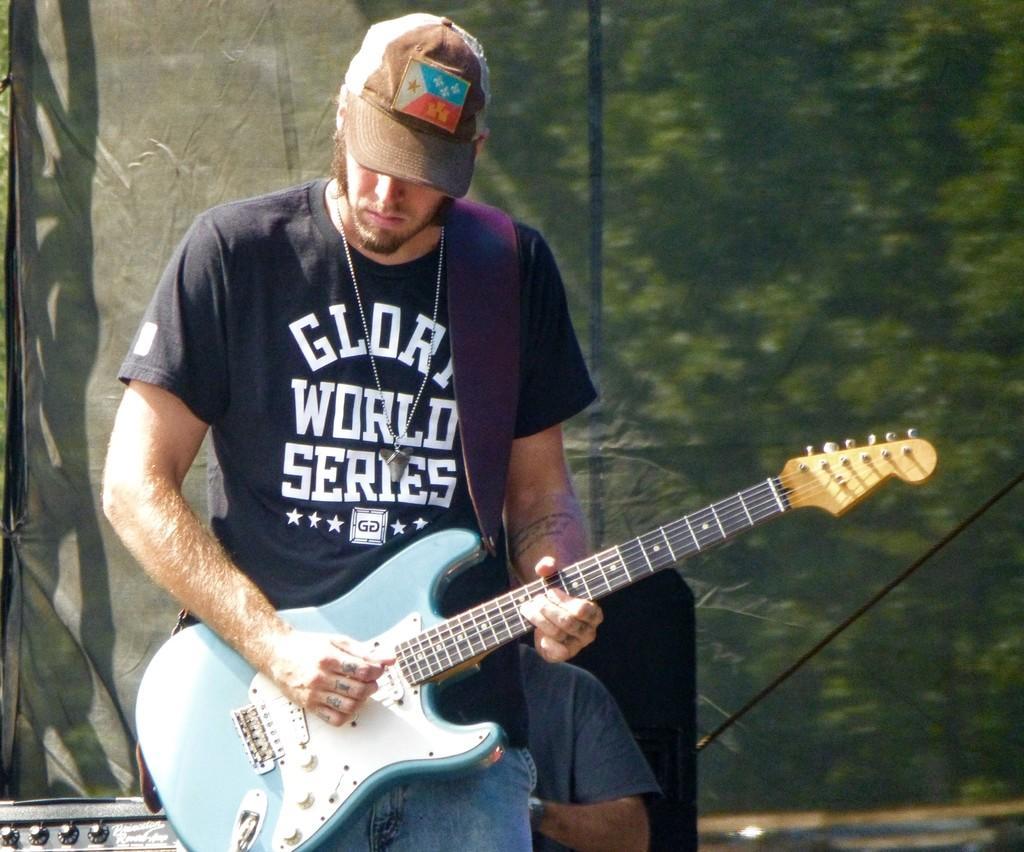Please provide a concise description of this image. In this image we can see a man standing by holding a guitar in his hands and playing it. In the background of the image we can see few trees. 